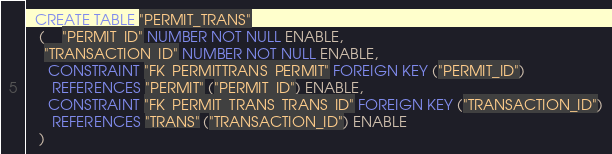Convert code to text. <code><loc_0><loc_0><loc_500><loc_500><_SQL_>
  CREATE TABLE "PERMIT_TRANS" 
   (	"PERMIT_ID" NUMBER NOT NULL ENABLE, 
	"TRANSACTION_ID" NUMBER NOT NULL ENABLE, 
	 CONSTRAINT "FK_PERMITTRANS_PERMIT" FOREIGN KEY ("PERMIT_ID")
	  REFERENCES "PERMIT" ("PERMIT_ID") ENABLE, 
	 CONSTRAINT "FK_PERMIT_TRANS_TRANS_ID" FOREIGN KEY ("TRANSACTION_ID")
	  REFERENCES "TRANS" ("TRANSACTION_ID") ENABLE
   ) </code> 